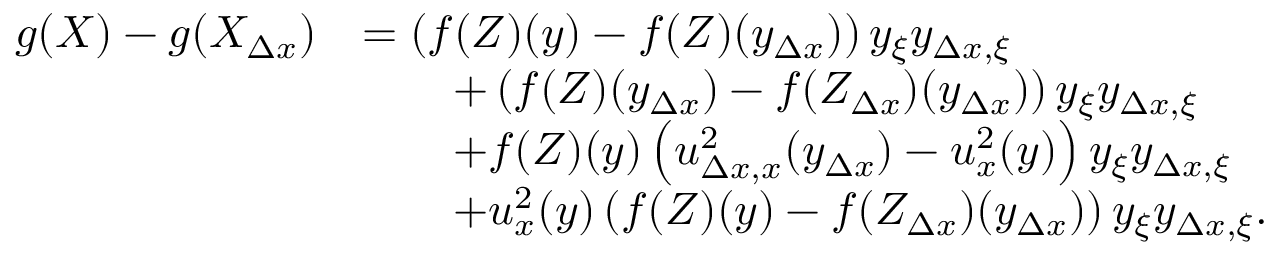Convert formula to latex. <formula><loc_0><loc_0><loc_500><loc_500>\begin{array} { r l } { g ( X ) - g ( X _ { \Delta x } ) } & { = \left ( f ( Z ) ( y ) - f ( Z ) ( y _ { \Delta x } ) \right ) y _ { \xi } y _ { \Delta x , \xi } } \\ & { \quad + \left ( f ( Z ) ( y _ { \Delta x } ) - f ( Z _ { \Delta x } ) ( y _ { \Delta x } ) \right ) y _ { \xi } y _ { \Delta x , \xi } } \\ & { \quad + f ( Z ) ( y ) \left ( u _ { \Delta x , x } ^ { 2 } ( y _ { \Delta x } ) - u _ { x } ^ { 2 } ( y ) \right ) y _ { \xi } y _ { \Delta x , \xi } } \\ & { \quad + u _ { x } ^ { 2 } ( y ) \left ( f ( Z ) ( y ) - f ( Z _ { \Delta x } ) ( y _ { \Delta x } ) \right ) y _ { \xi } y _ { \Delta x , \xi } . } \end{array}</formula> 